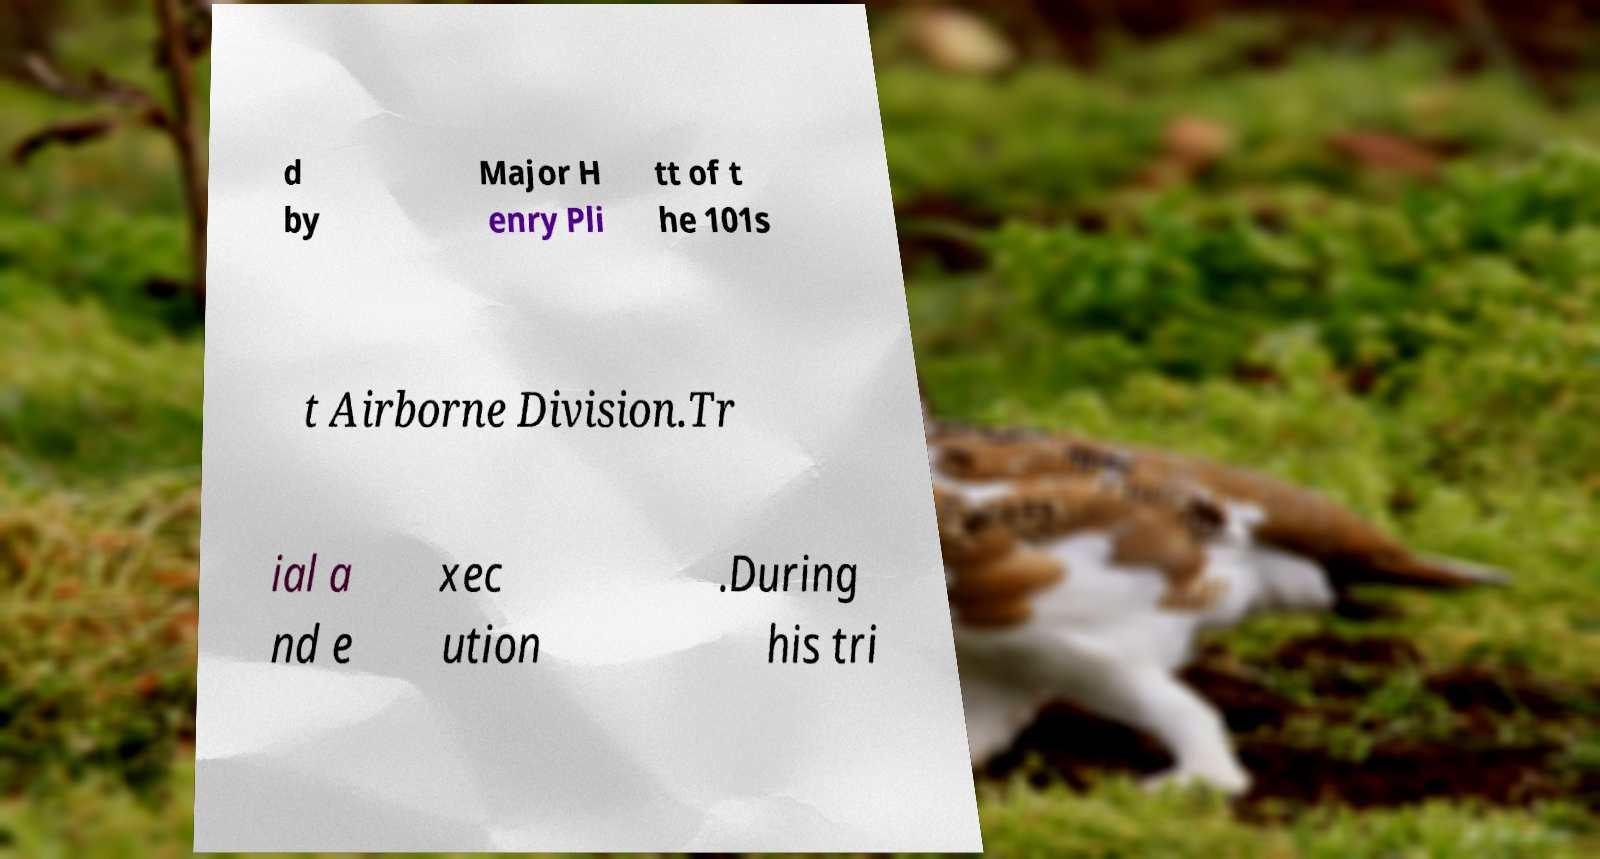I need the written content from this picture converted into text. Can you do that? d by Major H enry Pli tt of t he 101s t Airborne Division.Tr ial a nd e xec ution .During his tri 